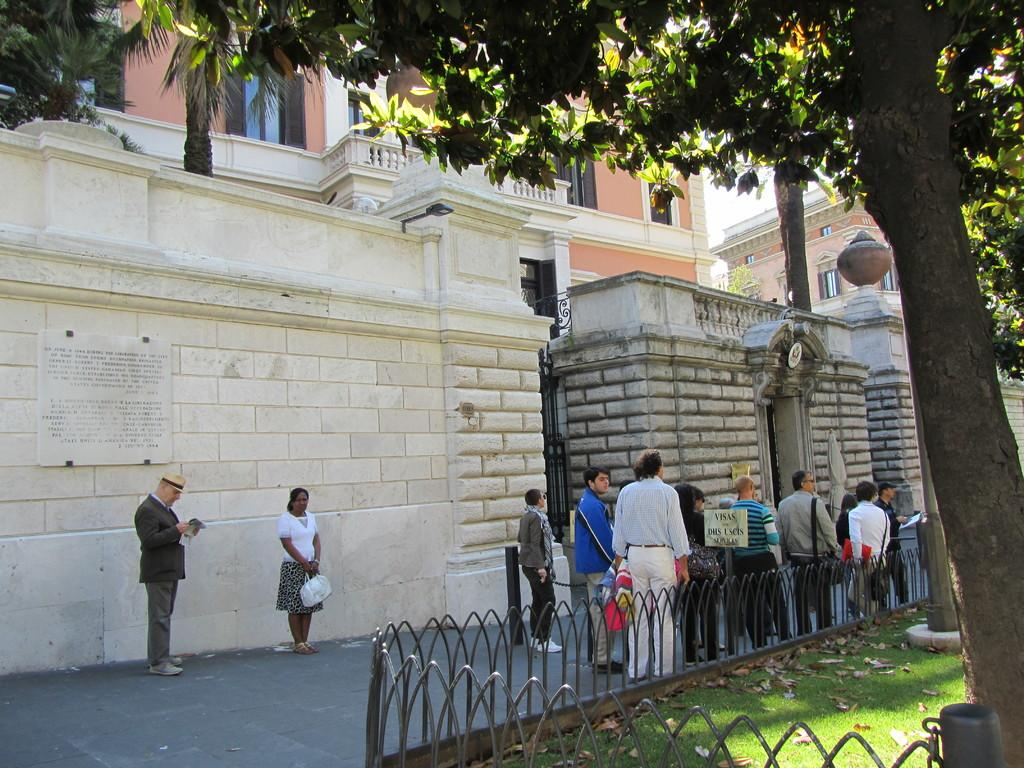How many people are in the image? There is a group of people in the image, but the exact number is not specified. What is the surface the people are standing on? The people are standing on the ground. What is the purpose of the fence in the image? The purpose of the fence is not specified, but it is present in the image. What type of vegetation is visible in the image? There is grass and trees visible in the image. What can be seen in the background of the image? There are buildings with windows in the background of the image. What type of plants are being coached by the person in the image? There is no person coaching plants in the image, and no plants are mentioned in the provided facts. 